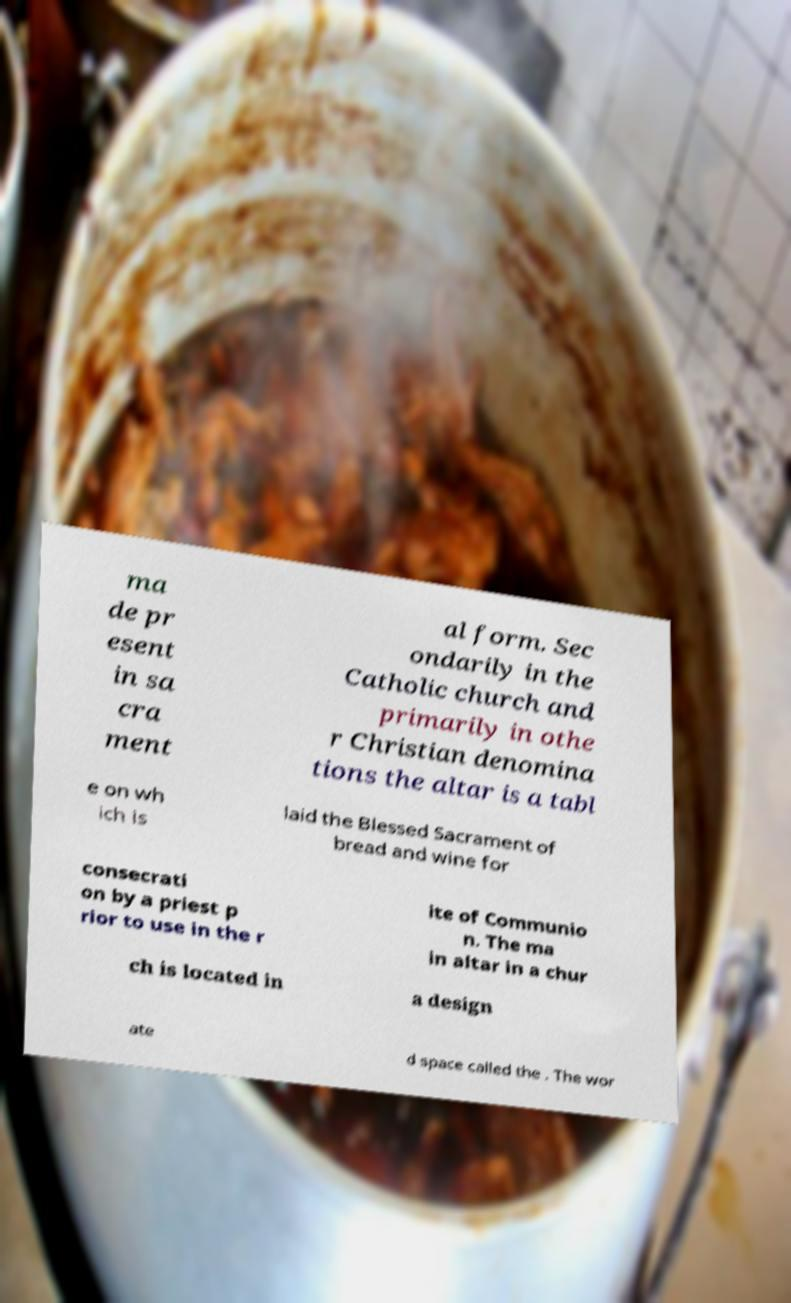There's text embedded in this image that I need extracted. Can you transcribe it verbatim? ma de pr esent in sa cra ment al form. Sec ondarily in the Catholic church and primarily in othe r Christian denomina tions the altar is a tabl e on wh ich is laid the Blessed Sacrament of bread and wine for consecrati on by a priest p rior to use in the r ite of Communio n. The ma in altar in a chur ch is located in a design ate d space called the . The wor 